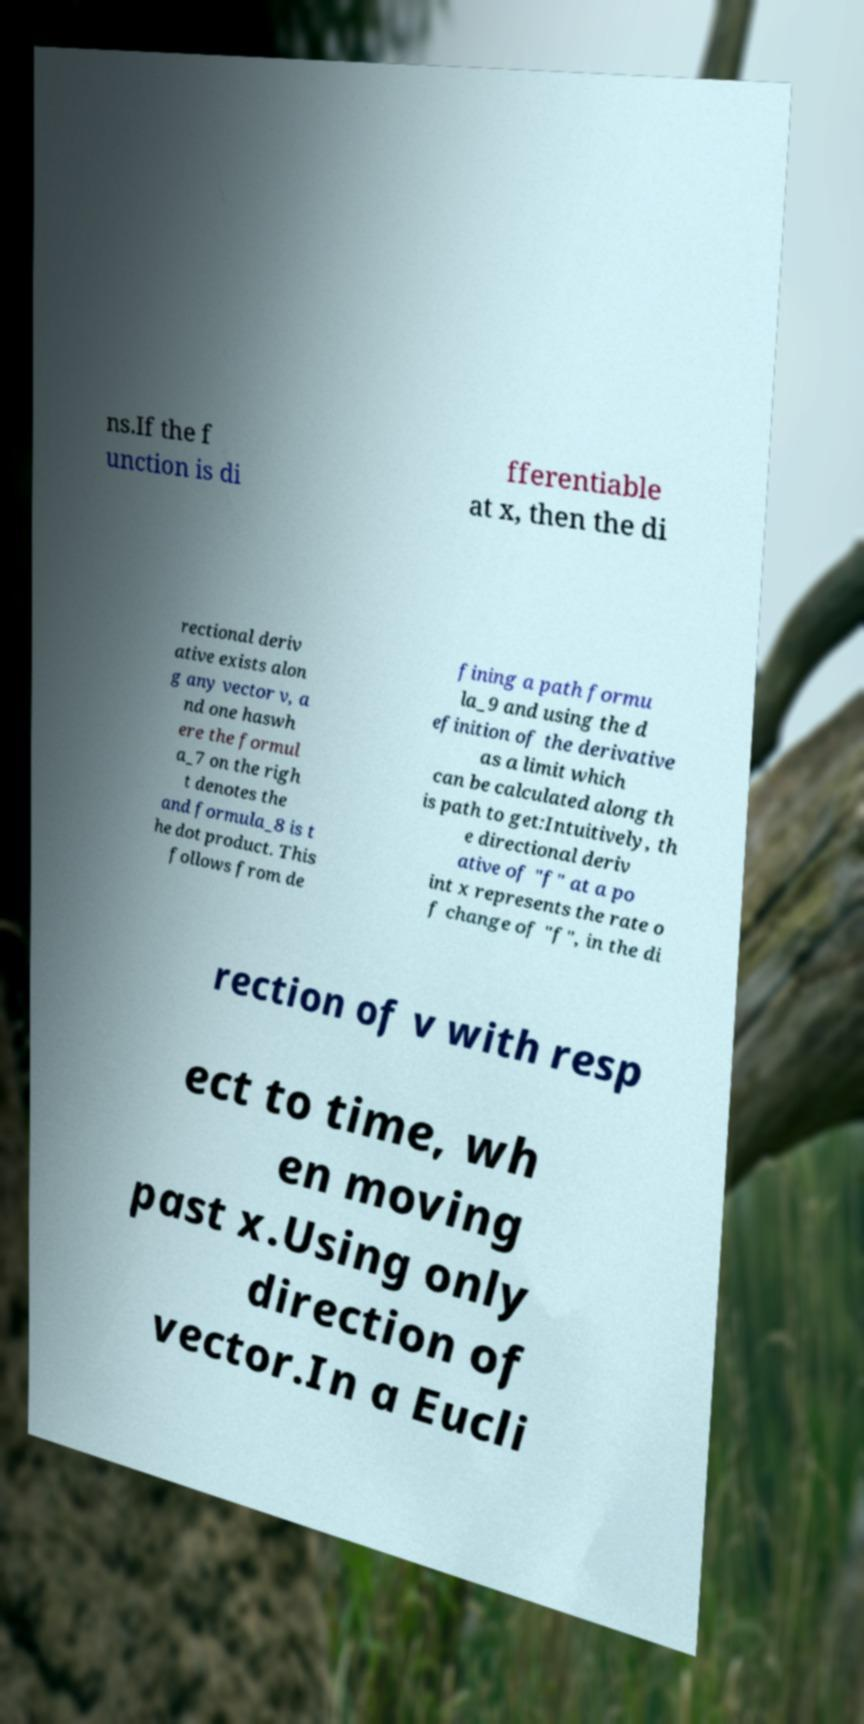There's text embedded in this image that I need extracted. Can you transcribe it verbatim? ns.If the f unction is di fferentiable at x, then the di rectional deriv ative exists alon g any vector v, a nd one haswh ere the formul a_7 on the righ t denotes the and formula_8 is t he dot product. This follows from de fining a path formu la_9 and using the d efinition of the derivative as a limit which can be calculated along th is path to get:Intuitively, th e directional deriv ative of "f" at a po int x represents the rate o f change of "f", in the di rection of v with resp ect to time, wh en moving past x.Using only direction of vector.In a Eucli 